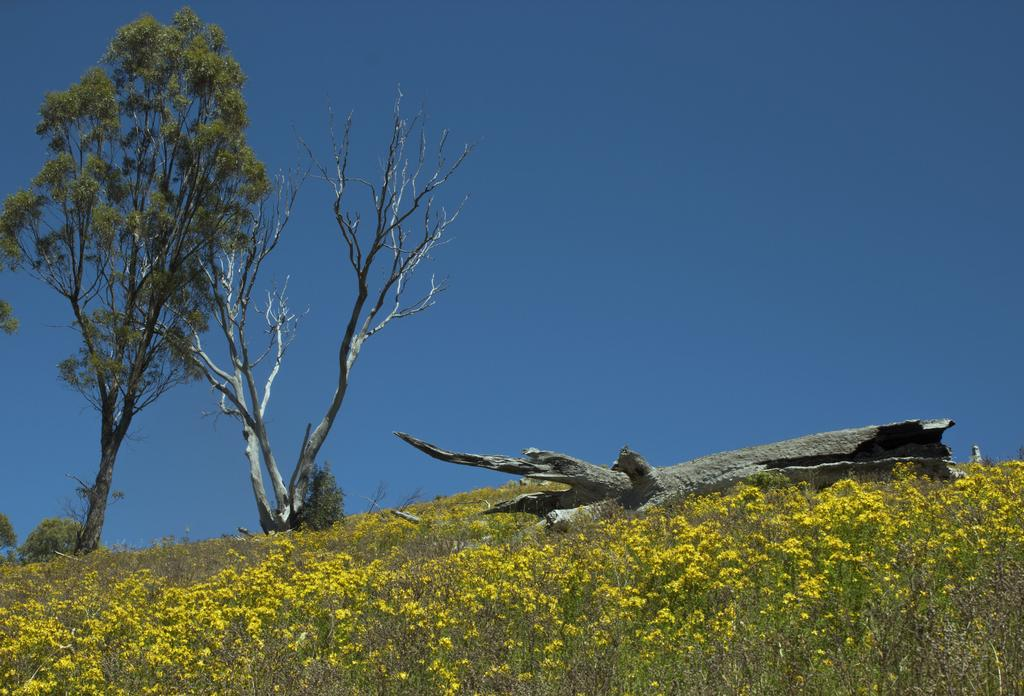What type of vegetation can be seen in the image? There are trees and plants in the image. Where are the flowers located in the image? The flowers are at the bottom of the image. What part of a tree is visible in the image? There is a tree trunk in the image. What is visible at the top of the image? The sky is visible at the top of the image. Is there a stream of oil flowing through the image? No, there is no stream of oil in the image. 